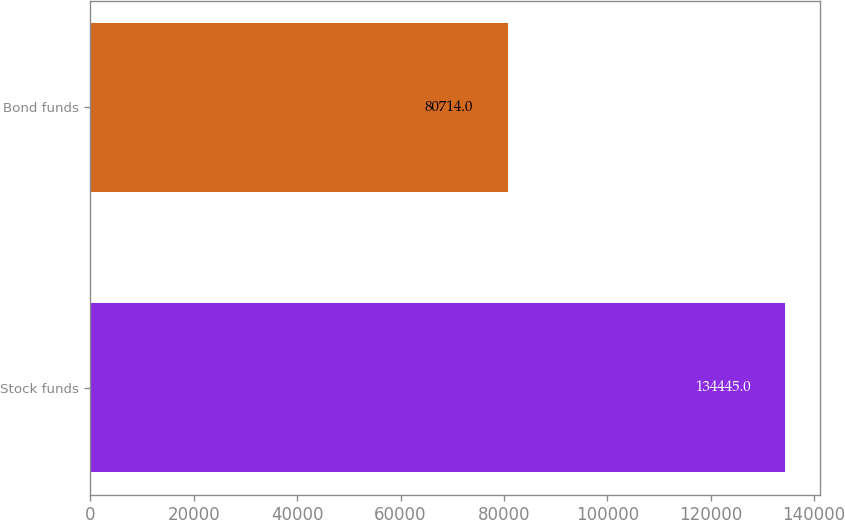Convert chart to OTSL. <chart><loc_0><loc_0><loc_500><loc_500><bar_chart><fcel>Stock funds<fcel>Bond funds<nl><fcel>134445<fcel>80714<nl></chart> 